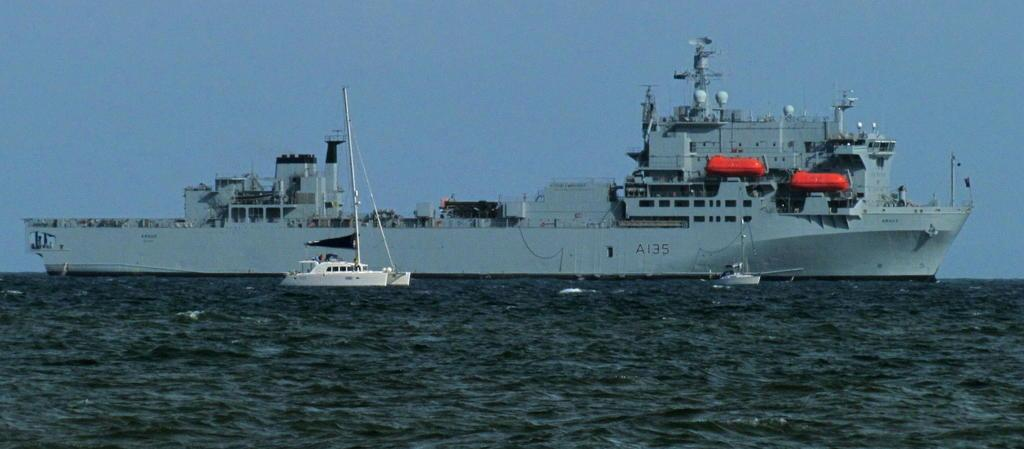<image>
Relay a brief, clear account of the picture shown. A large A135 carrier ship sails next to a smaller one. 